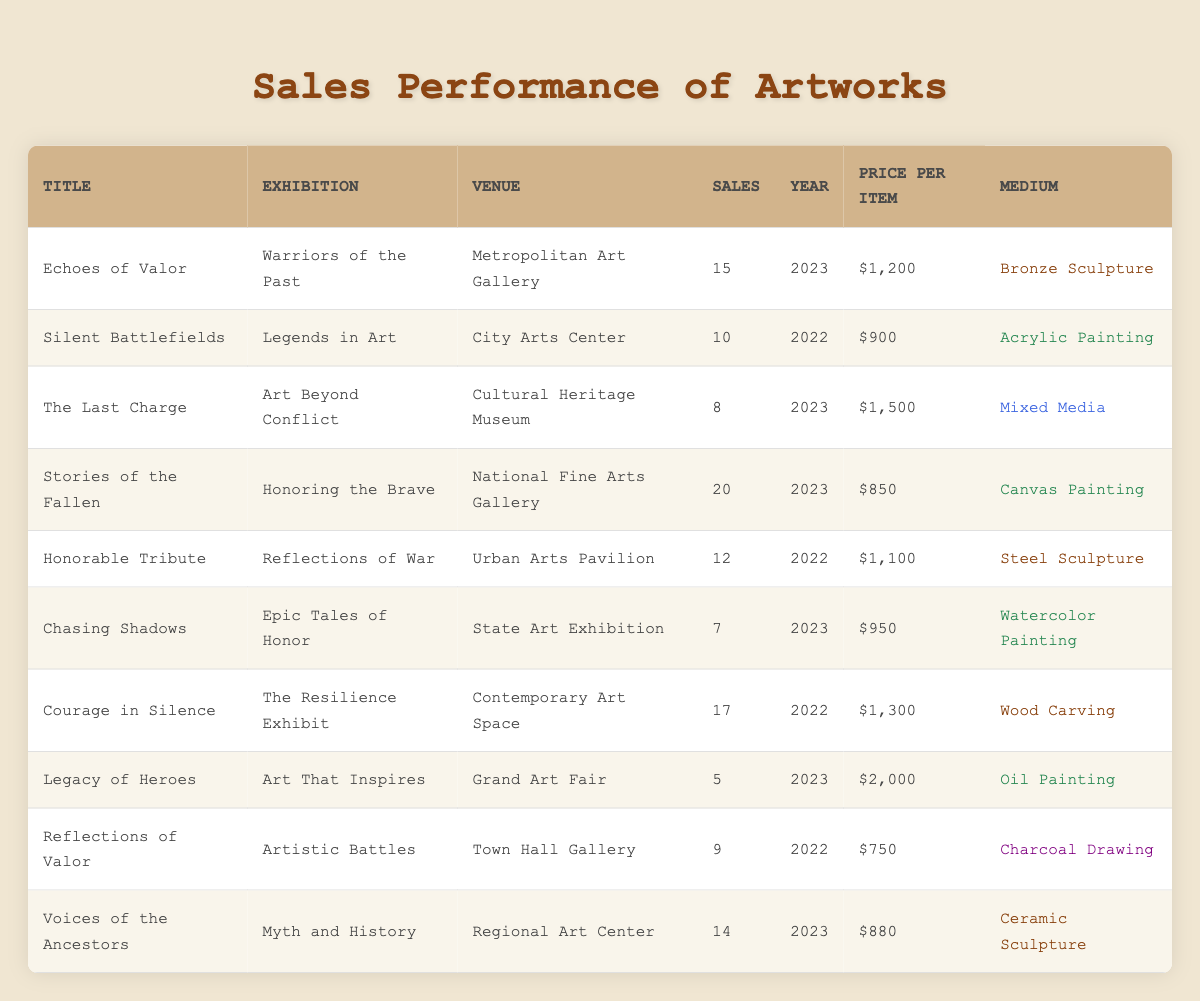What is the total number of sales for the artwork "Stories of the Fallen"? The table lists the artwork titles along with their sales figures. By finding "Stories of the Fallen," we see it has 20 sales.
Answer: 20 Which artwork sold the most in 2023? Looking at the sales numbers for artworks in 2023, "Stories of the Fallen" has the highest sales at 20 compared to "Echoes of Valor" with 15, "The Last Charge" with 8, "Chasing Shadows" with 7, "Legacy of Heroes" with 5, and "Voices of the Ancestors" with 14.
Answer: Stories of the Fallen What is the average price per item for artworks sold in 2022? The prices for 2022 artworks are $900 for "Silent Battlefields," $1,100 for "Honorable Tribute," and $1,300 for "Courage in Silence." Summing these gives $900 + $1,100 + $1,300 = $3,300. Dividing by 3 (the number of artworks) gives an average price of $3,300 / 3 = $1,100.
Answer: 1100 Did any artwork sell more than 15 units at the "Warriors of the Past" exhibition? The table shows that "Echoes of Valor" sold 15 units at the "Warriors of the Past" exhibition. Therefore, no artwork sold more than 15 units.
Answer: No What is the total revenue generated from artworks sold in the "Art That Inspires" exhibition? The table indicates that "Legacy of Heroes," priced at $2,000, sold 5 units in the "Art That Inspires" exhibition. Thus, revenue = 5 * $2,000 = $10,000.
Answer: 10000 Which medium had the least sales overall in 2023? Reviewing the sales data for 2023, "Chasing Shadows" (Watercolor Painting) had the least sales at 7, whereas the other artworks sold 8, 15, 14, and 20 respectively.
Answer: Watercolor Painting Was the total number of sales for "Courage in Silence" more than the combined sales of both the artworks "Legacy of Heroes" and "Chasing Shadows"? "Courage in Silence" sold 17 units, while "Legacy of Heroes" sold 5 and "Chasing Shadows" sold 7, which totals 5 + 7 = 12. Comparing 17 with 12 shows that 17 > 12.
Answer: Yes What is the least expensive artwork sold in 2023? From the 2023 artworks, "Legacy of Heroes" is priced at $2,000, "Voices of the Ancestors" at $880, "Chasing Shadows" at $950, "The Last Charge" at $1,500, "Echoes of Valor" at $1,200, and "Stories of the Fallen" at $850. So, the least expensive is "Stories of the Fallen."
Answer: Stories of the Fallen What was the total sales count for all artworks in the "Honoring the Brave" exhibition? The table shows that "Stories of the Fallen" was sold at the "Honoring the Brave" exhibition, with a total of 20 sales. Thus, the total sales count is 20.
Answer: 20 